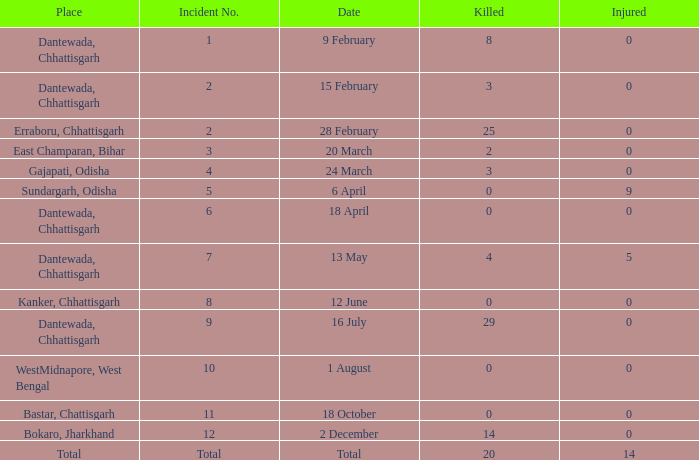How many people were injured in total in East Champaran, Bihar with more than 2 people killed? 0.0. 